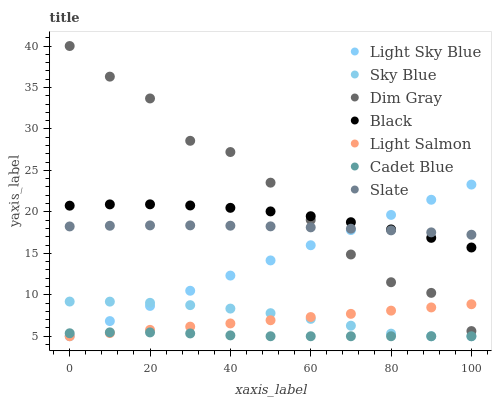Does Cadet Blue have the minimum area under the curve?
Answer yes or no. Yes. Does Dim Gray have the maximum area under the curve?
Answer yes or no. Yes. Does Slate have the minimum area under the curve?
Answer yes or no. No. Does Slate have the maximum area under the curve?
Answer yes or no. No. Is Light Salmon the smoothest?
Answer yes or no. Yes. Is Dim Gray the roughest?
Answer yes or no. Yes. Is Cadet Blue the smoothest?
Answer yes or no. No. Is Cadet Blue the roughest?
Answer yes or no. No. Does Light Salmon have the lowest value?
Answer yes or no. Yes. Does Slate have the lowest value?
Answer yes or no. No. Does Dim Gray have the highest value?
Answer yes or no. Yes. Does Slate have the highest value?
Answer yes or no. No. Is Light Salmon less than Slate?
Answer yes or no. Yes. Is Dim Gray greater than Sky Blue?
Answer yes or no. Yes. Does Light Salmon intersect Dim Gray?
Answer yes or no. Yes. Is Light Salmon less than Dim Gray?
Answer yes or no. No. Is Light Salmon greater than Dim Gray?
Answer yes or no. No. Does Light Salmon intersect Slate?
Answer yes or no. No. 